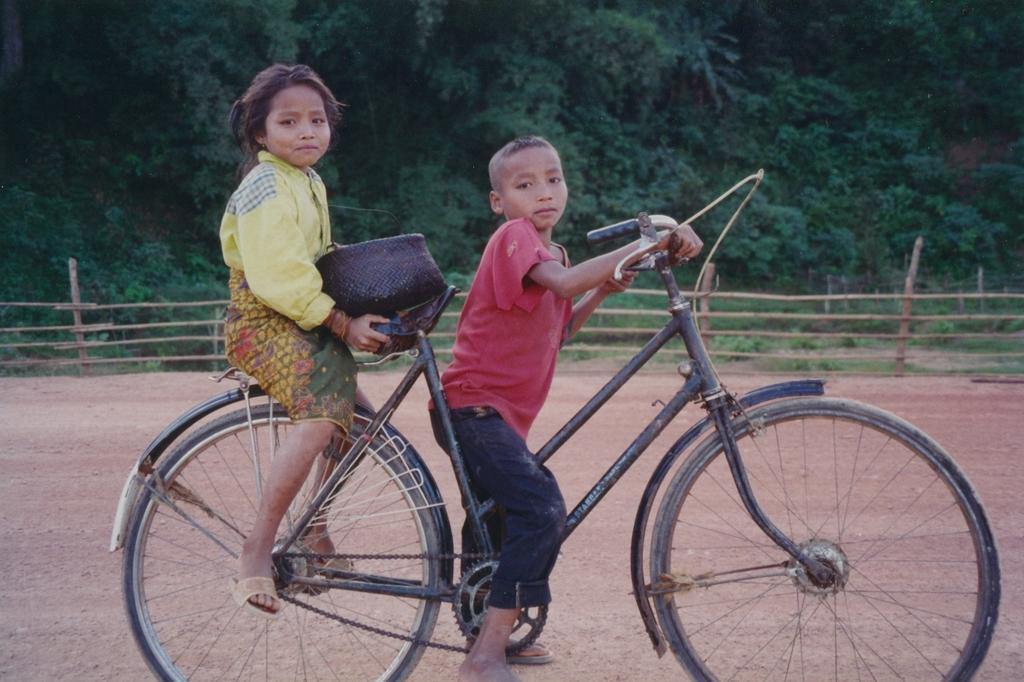How many people are in the image? There are two people in the image, a girl and a boy. What are the boy and girl doing in the image? The boy is sitting on a bicycle, and the girl is sitting on the bicycle with the boy. What are the boy and girl holding on the bicycle? The boy is holding the handle of the bicycle, and the girl is holding the seat of the bicycle. What is in front of the girl? There is a container in front of the girl. What can be seen in the distance in the image? Trees and a fence are visible in the distance. What caption would best describe the image? There is no caption provided with the image, so it cannot be determined. Is the grandmother having trouble with the bicycle in the image? There is no grandmother present in the image, so it cannot be determined if she is having trouble with the bicycle. 